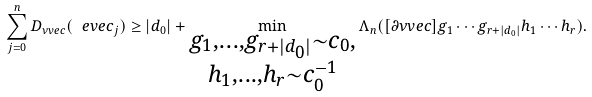Convert formula to latex. <formula><loc_0><loc_0><loc_500><loc_500>\sum _ { j = 0 } ^ { n } D _ { \nu v e c } ( \ e v e c _ { j } ) \geq | d _ { 0 } | + \min _ { \substack { g _ { 1 } , \dots , g _ { r + | d _ { 0 } | } \sim c _ { 0 } , \\ h _ { 1 } , \dots , h _ { r } \sim c _ { 0 } ^ { - 1 } } } \Lambda _ { n } ( [ \partial \nu v e c ] g _ { 1 } \cdots g _ { r + | d _ { 0 } | } h _ { 1 } \cdots h _ { r } ) .</formula> 